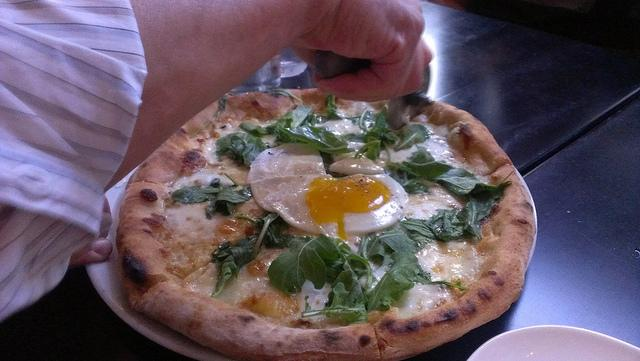What animal did the topmost ingredient come from? Please explain your reasoning. chicken. Eggs come from chickens. 